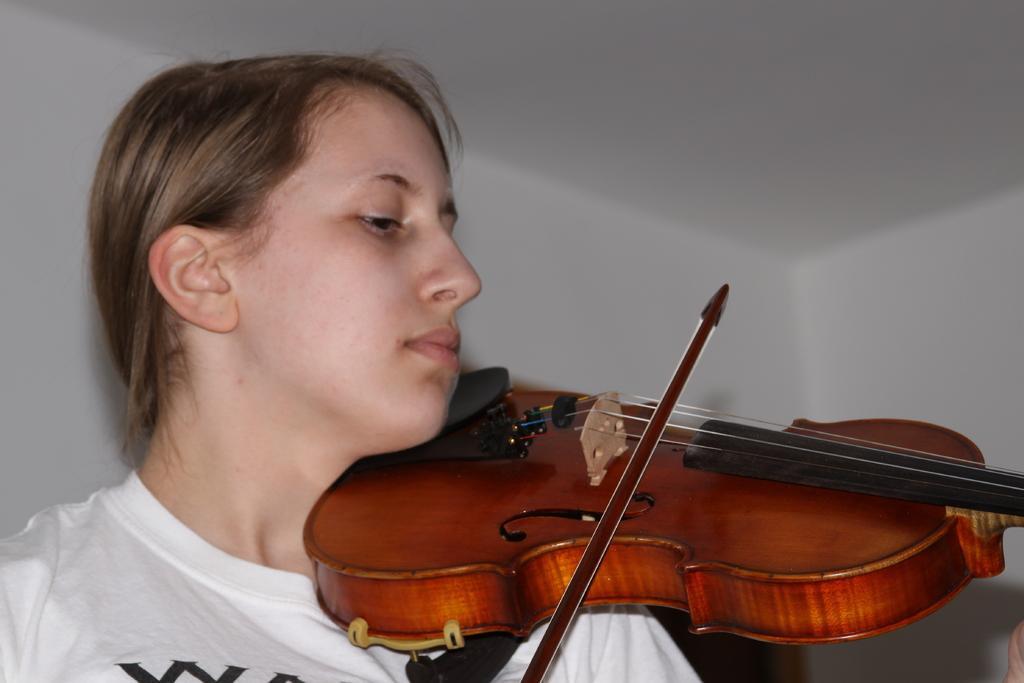Could you give a brief overview of what you see in this image? In this image we can see a person playing a violin and in the background, we can see the wall. 